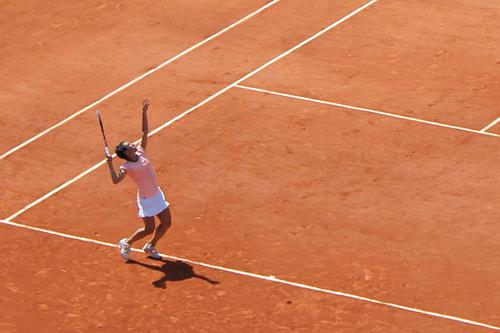Question: who is playing tennis?
Choices:
A. Young girls.
B. An elderly couple.
C. A woman.
D. A student.
Answer with the letter. Answer: D Question: what day of the week is it?
Choices:
A. Wednesday.
B. Thursday.
C. Sunday.
D. Monday.
Answer with the letter. Answer: D Question: what is the weather like?
Choices:
A. Sunny.
B. Cold.
C. Dreary.
D. Rainy.
Answer with the letter. Answer: A Question: when was this picture taken?
Choices:
A. Today.
B. Yesterday.
C. June.
D. August.
Answer with the letter. Answer: B 